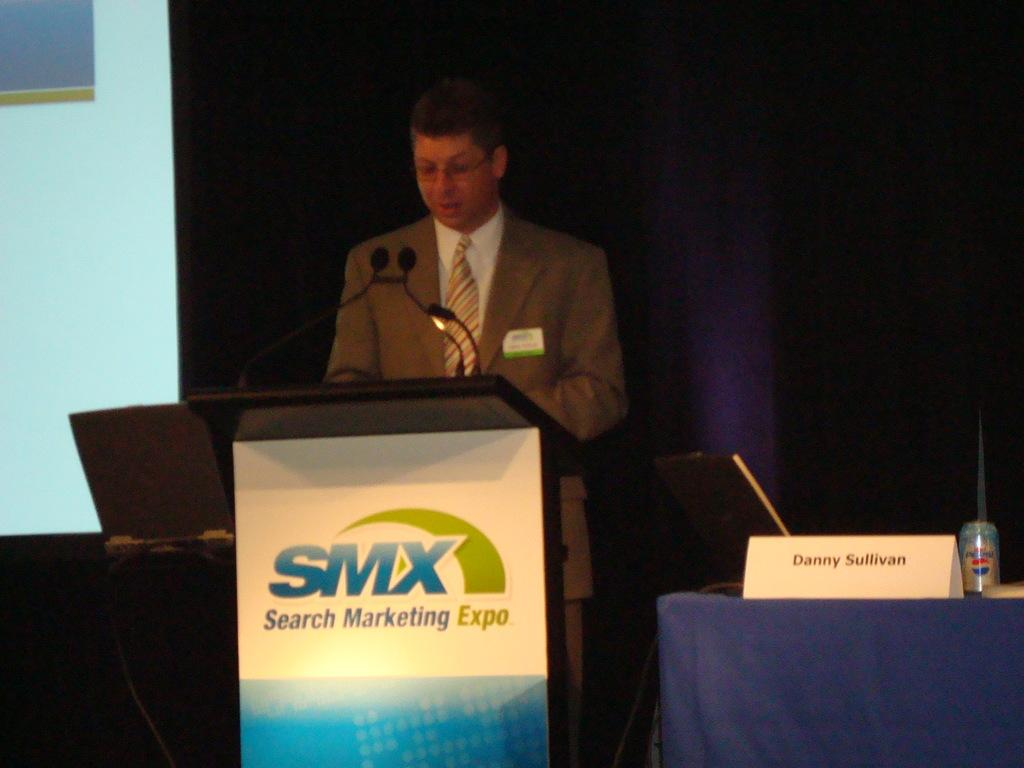<image>
Offer a succinct explanation of the picture presented. A men at a podium with a sign on it for SMX 